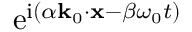<formula> <loc_0><loc_0><loc_500><loc_500>e ^ { i ( \alpha k _ { 0 } \cdot x - \beta \omega _ { 0 } t ) }</formula> 